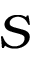<formula> <loc_0><loc_0><loc_500><loc_500>S</formula> 